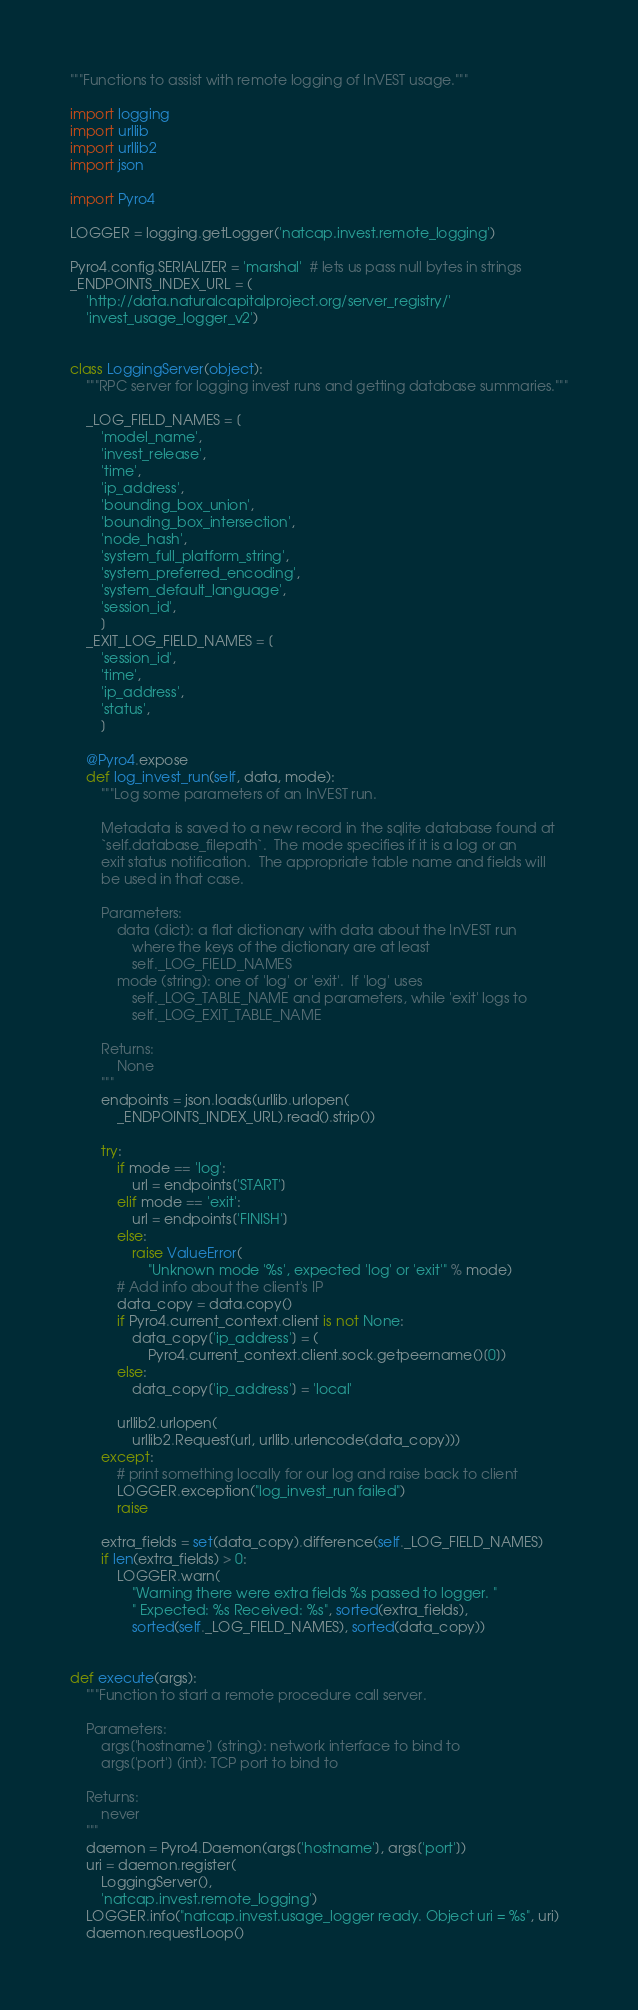<code> <loc_0><loc_0><loc_500><loc_500><_Python_>"""Functions to assist with remote logging of InVEST usage."""

import logging
import urllib
import urllib2
import json

import Pyro4

LOGGER = logging.getLogger('natcap.invest.remote_logging')

Pyro4.config.SERIALIZER = 'marshal'  # lets us pass null bytes in strings
_ENDPOINTS_INDEX_URL = (
    'http://data.naturalcapitalproject.org/server_registry/'
    'invest_usage_logger_v2')


class LoggingServer(object):
    """RPC server for logging invest runs and getting database summaries."""

    _LOG_FIELD_NAMES = [
        'model_name',
        'invest_release',
        'time',
        'ip_address',
        'bounding_box_union',
        'bounding_box_intersection',
        'node_hash',
        'system_full_platform_string',
        'system_preferred_encoding',
        'system_default_language',
        'session_id',
        ]
    _EXIT_LOG_FIELD_NAMES = [
        'session_id',
        'time',
        'ip_address',
        'status',
        ]

    @Pyro4.expose
    def log_invest_run(self, data, mode):
        """Log some parameters of an InVEST run.

        Metadata is saved to a new record in the sqlite database found at
        `self.database_filepath`.  The mode specifies if it is a log or an
        exit status notification.  The appropriate table name and fields will
        be used in that case.

        Parameters:
            data (dict): a flat dictionary with data about the InVEST run
                where the keys of the dictionary are at least
                self._LOG_FIELD_NAMES
            mode (string): one of 'log' or 'exit'.  If 'log' uses
                self._LOG_TABLE_NAME and parameters, while 'exit' logs to
                self._LOG_EXIT_TABLE_NAME

        Returns:
            None
        """
        endpoints = json.loads(urllib.urlopen(
            _ENDPOINTS_INDEX_URL).read().strip())

        try:
            if mode == 'log':
                url = endpoints['START']
            elif mode == 'exit':
                url = endpoints['FINISH']
            else:
                raise ValueError(
                    "Unknown mode '%s', expected 'log' or 'exit'" % mode)
            # Add info about the client's IP
            data_copy = data.copy()
            if Pyro4.current_context.client is not None:
                data_copy['ip_address'] = (
                    Pyro4.current_context.client.sock.getpeername()[0])
            else:
                data_copy['ip_address'] = 'local'

            urllib2.urlopen(
                urllib2.Request(url, urllib.urlencode(data_copy)))
        except:
            # print something locally for our log and raise back to client
            LOGGER.exception("log_invest_run failed")
            raise

        extra_fields = set(data_copy).difference(self._LOG_FIELD_NAMES)
        if len(extra_fields) > 0:
            LOGGER.warn(
                "Warning there were extra fields %s passed to logger. "
                " Expected: %s Received: %s", sorted(extra_fields),
                sorted(self._LOG_FIELD_NAMES), sorted(data_copy))


def execute(args):
    """Function to start a remote procedure call server.

    Parameters:
        args['hostname'] (string): network interface to bind to
        args['port'] (int): TCP port to bind to

    Returns:
        never
    """
    daemon = Pyro4.Daemon(args['hostname'], args['port'])
    uri = daemon.register(
        LoggingServer(),
        'natcap.invest.remote_logging')
    LOGGER.info("natcap.invest.usage_logger ready. Object uri = %s", uri)
    daemon.requestLoop()
</code> 